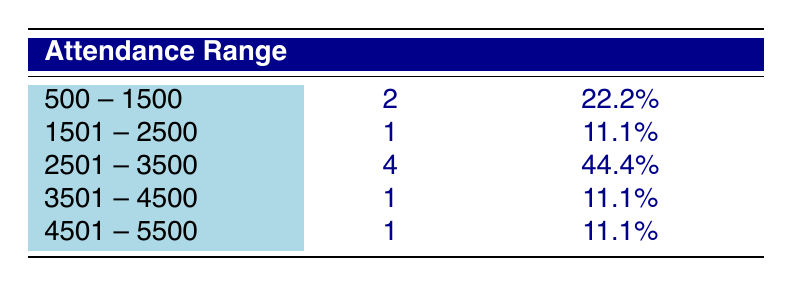What is the attendance range with the highest frequency? The table shows that the attendance range of 2501 to 3500 has the highest frequency, with 4 occurrences.
Answer: 2501 -- 3500 How many matches had attendance figures between 500 and 1500? According to the table, there are 2 matches that had attendance between 500 and 1500.
Answer: 2 What is the total attendance for the events that had attendance above 3500? The events with attendance above 3500 are: 4000 (2022) and 5000 (2023). Adding these together: 4000 + 5000 = 9000.
Answer: 9000 Did more matches have attendance below 3500 compared to above 3500? The matches with attendance below 3500 are 6, while those above are 3. So, more matches had attendance below 3500.
Answer: Yes What percentage of matches had an attendance of 4501 or more? There is 1 match in the attendance range of 4501 to 5500 out of a total of 9 matches. To calculate the percentage: (1/9)*100 = 11.1%.
Answer: 11.1% What is the average attendance for all the events listed in the table? The total attendance is 1500 + 3800 + 2200 + 2700 + 3000 + 800 + 3200 + 4000 + 5000 = 22800. With 9 matches, the average is 22800 / 9 = 2533.33.
Answer: 2533.33 Which attendance range has the least number of matches? The ranges 1501 to 2500 and 3501 to 4500 both have only 1 match each, which is the least for any attendance range.
Answer: 1501 -- 2500 and 3501 -- 4500 How many matches had an attendance between 2501 and 3500 inclusive? The table indicates that 4 matches fall within the attendance range of 2501 to 3500 inclusive.
Answer: 4 What was the relative frequency of matches with attendance between 1501 and 2500? There was 1 match in the 1501 to 2500 range out of a total of 9 matches, making the relative frequency (1/9)*100 = 11.1%.
Answer: 11.1% 